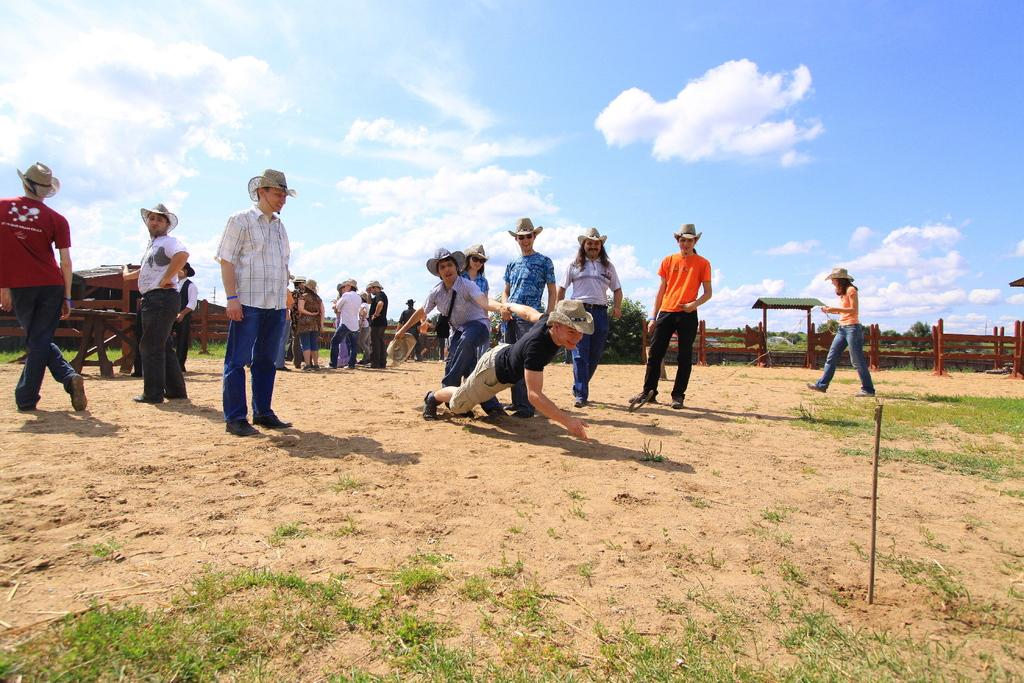What are the two persons in the middle of the image doing? The two persons are playing a game in the middle of the image. How many people are observing the game? Many people are standing and observing the game. What are the people wearing on their heads? The people are wearing hats. What can be seen at the top of the image? The sky is visible at the top of the image. What type of cart is visible on the floor in the image? There is no cart visible on the floor in the image. How many doors can be seen in the image? There are no doors present in the image. 